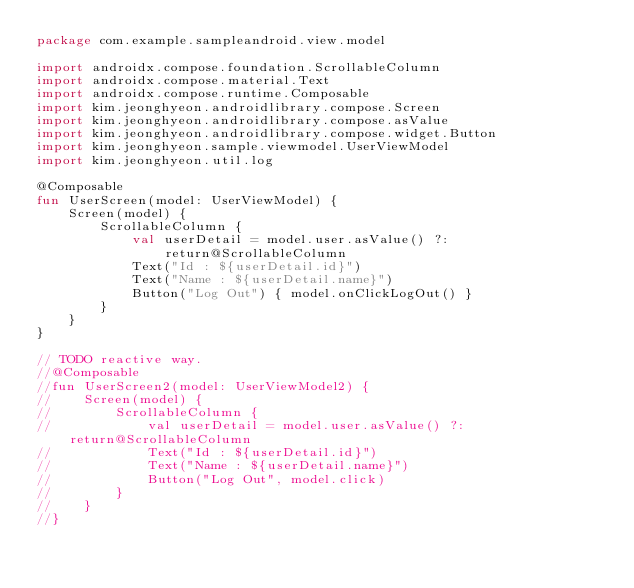<code> <loc_0><loc_0><loc_500><loc_500><_Kotlin_>package com.example.sampleandroid.view.model

import androidx.compose.foundation.ScrollableColumn
import androidx.compose.material.Text
import androidx.compose.runtime.Composable
import kim.jeonghyeon.androidlibrary.compose.Screen
import kim.jeonghyeon.androidlibrary.compose.asValue
import kim.jeonghyeon.androidlibrary.compose.widget.Button
import kim.jeonghyeon.sample.viewmodel.UserViewModel
import kim.jeonghyeon.util.log

@Composable
fun UserScreen(model: UserViewModel) {
    Screen(model) {
        ScrollableColumn {
            val userDetail = model.user.asValue() ?: return@ScrollableColumn
            Text("Id : ${userDetail.id}")
            Text("Name : ${userDetail.name}")
            Button("Log Out") { model.onClickLogOut() }
        }
    }
}

// TODO reactive way.
//@Composable
//fun UserScreen2(model: UserViewModel2) {
//    Screen(model) {
//        ScrollableColumn {
//            val userDetail = model.user.asValue() ?: return@ScrollableColumn
//            Text("Id : ${userDetail.id}")
//            Text("Name : ${userDetail.name}")
//            Button("Log Out", model.click)
//        }
//    }
//}</code> 